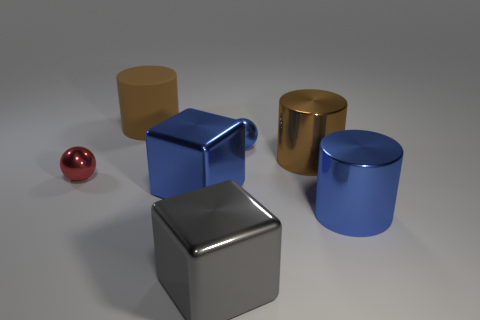Add 1 big blue objects. How many objects exist? 8 Subtract all blocks. How many objects are left? 5 Add 3 large brown things. How many large brown things exist? 5 Subtract 0 purple cubes. How many objects are left? 7 Subtract all large gray metallic things. Subtract all large blue cylinders. How many objects are left? 5 Add 4 big brown matte objects. How many big brown matte objects are left? 5 